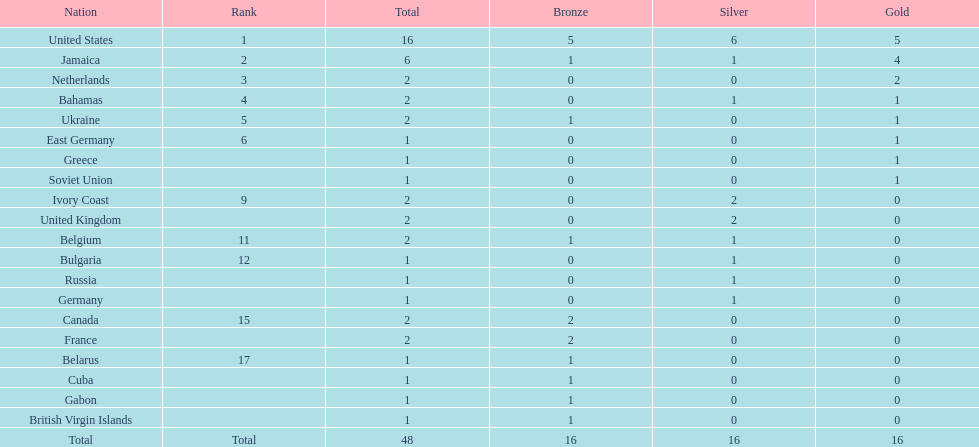What country won more gold medals than any other? United States. 